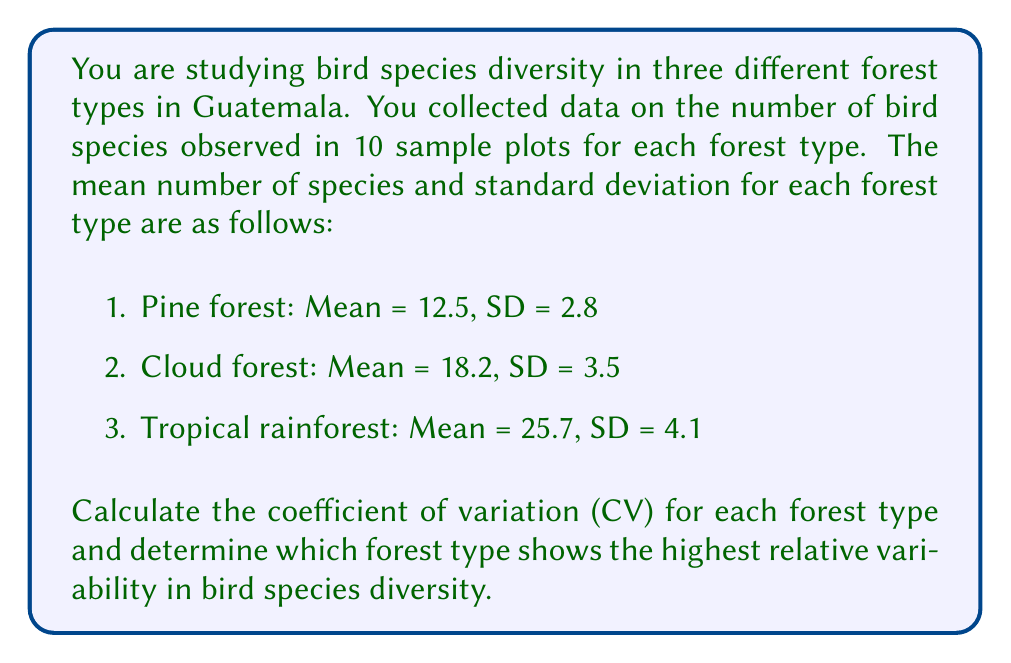Solve this math problem. To solve this problem, we need to calculate the coefficient of variation (CV) for each forest type and compare them. The CV is a measure of relative variability that allows us to compare the variability of datasets with different means.

The formula for CV is:

$$ CV = \frac{\text{Standard Deviation}}{\text{Mean}} \times 100\% $$

Let's calculate the CV for each forest type:

1. Pine forest:
$$ CV_{pine} = \frac{2.8}{12.5} \times 100\% = 22.4\% $$

2. Cloud forest:
$$ CV_{cloud} = \frac{3.5}{18.2} \times 100\% = 19.2\% $$

3. Tropical rainforest:
$$ CV_{rainforest} = \frac{4.1}{25.7} \times 100\% = 16.0\% $$

Now, we compare the CV values:

Pine forest: 22.4%
Cloud forest: 19.2%
Tropical rainforest: 16.0%

The highest CV value indicates the forest type with the highest relative variability in bird species diversity. In this case, the pine forest has the highest CV at 22.4%.
Answer: Pine forest (CV = 22.4%) 